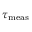<formula> <loc_0><loc_0><loc_500><loc_500>\tau _ { m e a s }</formula> 